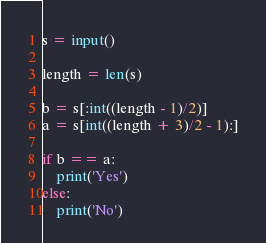<code> <loc_0><loc_0><loc_500><loc_500><_Python_>s = input()

length = len(s)

b = s[:int((length - 1)/2)]
a = s[int((length + 3)/2 - 1):]

if b == a:
    print('Yes')
else:
    print('No')</code> 